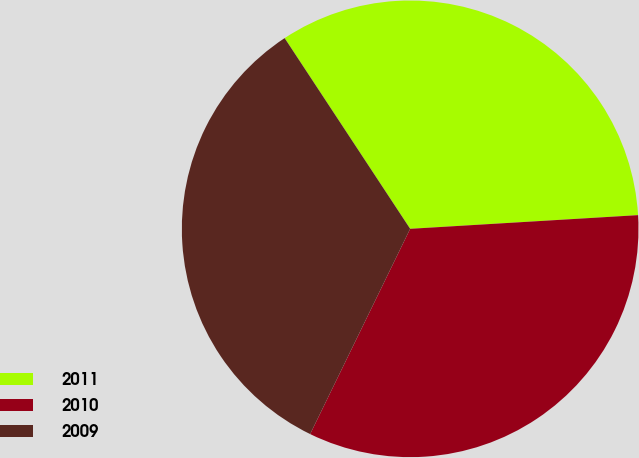Convert chart. <chart><loc_0><loc_0><loc_500><loc_500><pie_chart><fcel>2011<fcel>2010<fcel>2009<nl><fcel>33.31%<fcel>33.17%<fcel>33.52%<nl></chart> 